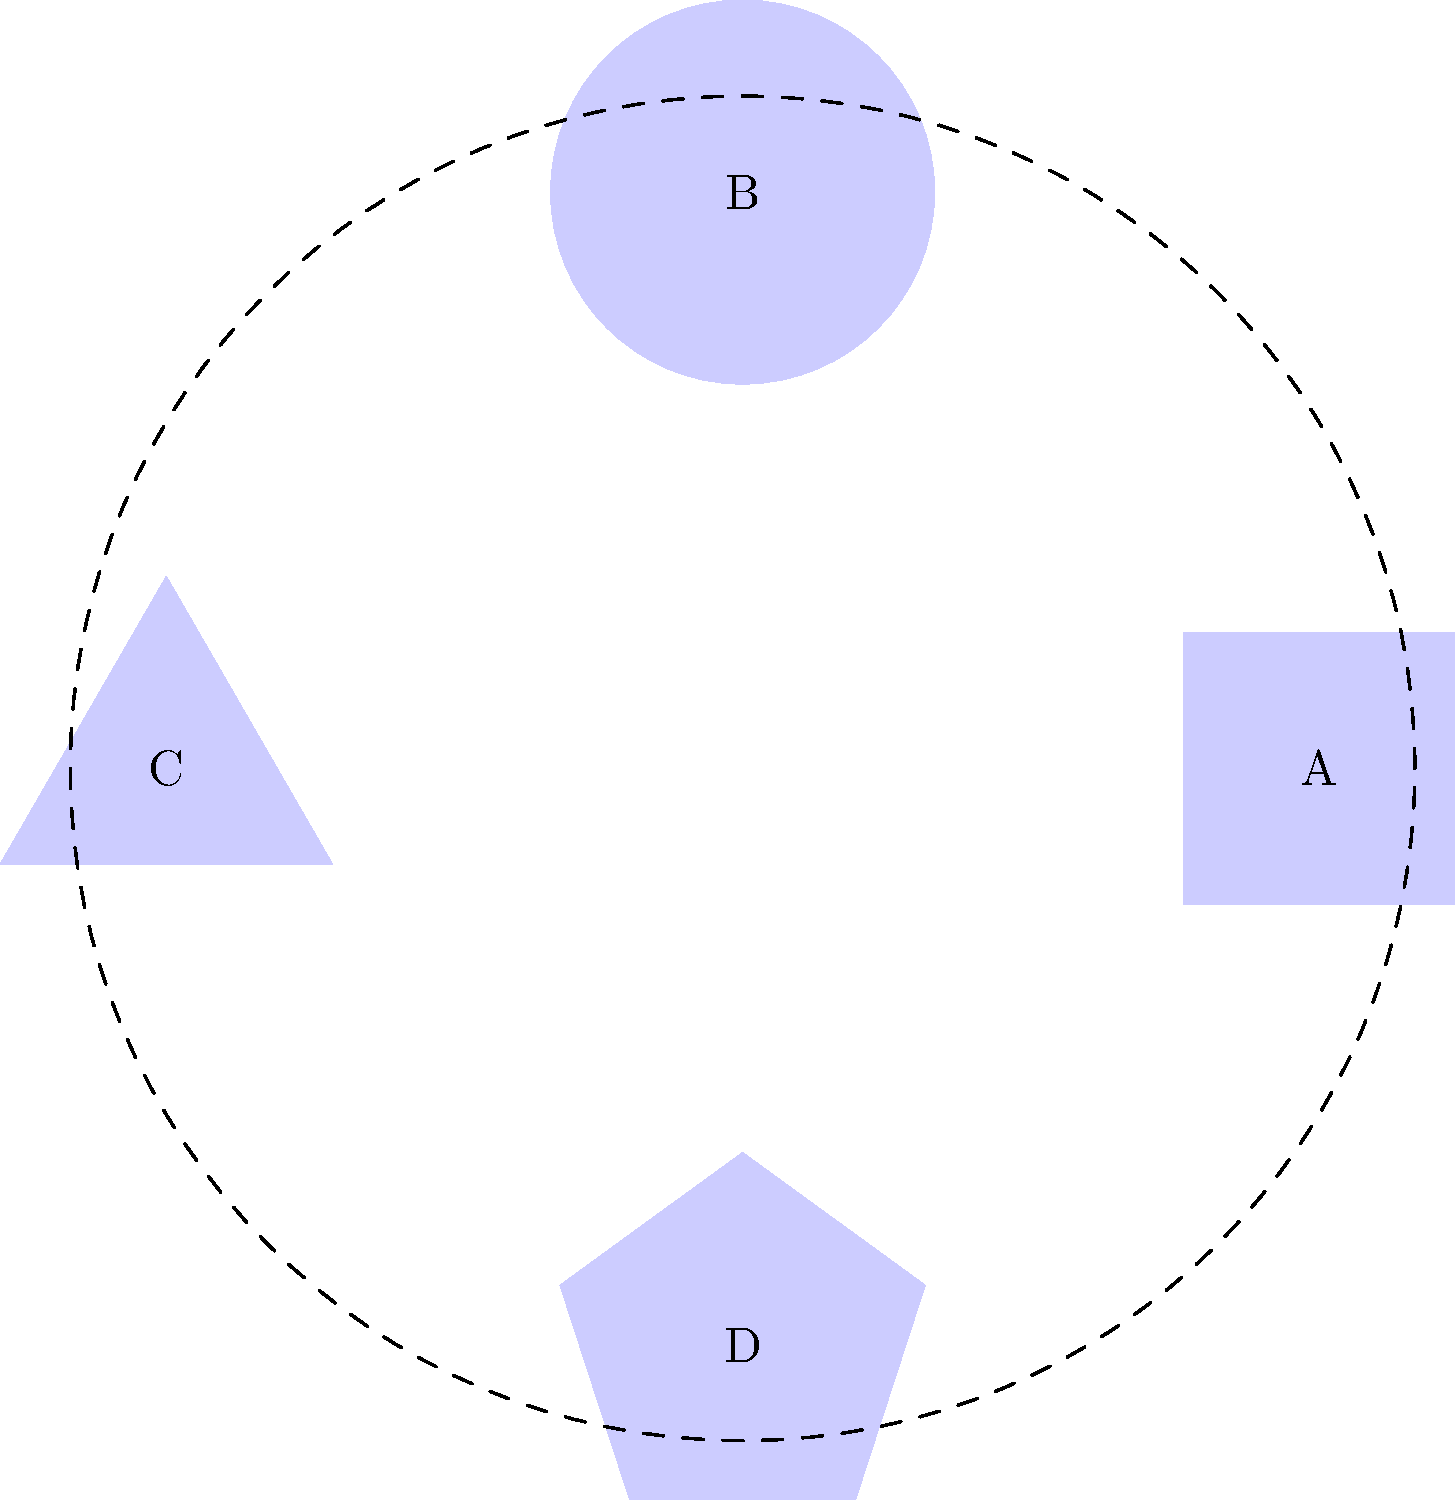The diagram shows four financial product icons (A, B, C, D) arranged around a circle. If icon A represents "Nonprofit Checking", B represents "Community Investment Fund", C represents "Microloan Program", and D represents "Sustainable Savings Account", how many degrees clockwise should each icon be rotated to match its correct position based on the following descriptions:

1. The Sustainable Savings Account should be opposite the Nonprofit Checking.
2. The Microloan Program should be to the immediate right of the Nonprofit Checking.
3. The Community Investment Fund should be between the Microloan Program and the Sustainable Savings Account. To solve this problem, we need to follow these steps:

1. Identify the current positions of the icons:
   A (top), B (right), C (bottom), D (left)

2. Determine the correct positions based on the descriptions:
   - Nonprofit Checking should be opposite Sustainable Savings Account
   - Microloan Program should be to the immediate right of Nonprofit Checking
   - Community Investment Fund should be between Microloan Program and Sustainable Savings Account

3. Assign the correct positions:
   - Nonprofit Checking: top (current position of A)
   - Microloan Program: right (current position of B)
   - Community Investment Fund: bottom (current position of C)
   - Sustainable Savings Account: left (current position of D)

4. Calculate the rotations needed:
   - A (Nonprofit Checking): already in correct position, rotation = 0°
   - B (Community Investment Fund): needs to move 2 positions clockwise, rotation = 180°
   - C (Microloan Program): needs to move 1 position clockwise, rotation = 90°
   - D (Sustainable Savings Account): already in correct position, rotation = 0°
Answer: A: 0°, B: 180°, C: 90°, D: 0° 